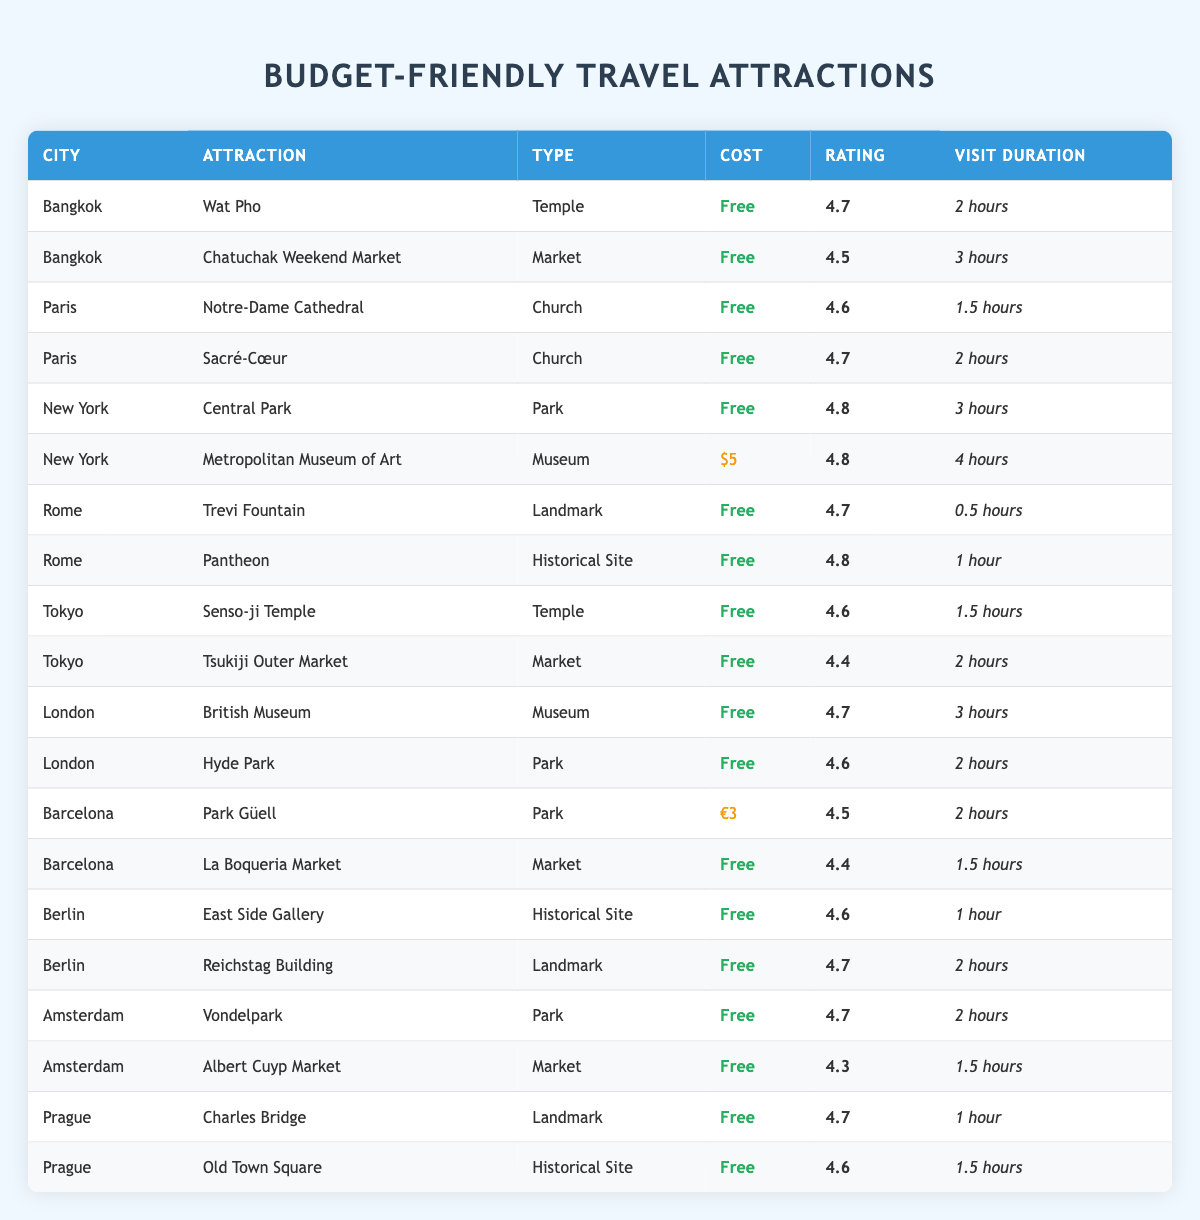What are the free attractions in Paris? In the table, the attractions in Paris that are marked as free are Notre-Dame Cathedral and Sacré-Cœur. I can identify these by checking the Cost column for a value of 0 associated with Paris.
Answer: Notre-Dame Cathedral, Sacré-Cœur Which city features the highest-rated free park? Central Park in New York has a rating of 4.8, the highest for a park in the table. While there are other free parks, such as Hyde Park and Vondelpark, their ratings are 4.6 and 4.7, respectively.
Answer: New York How many hours can you spend visiting the free attractions in Bangkok? The visit durations for free attractions in Bangkok are Wat Pho (2 hours) and Chatuchak Weekend Market (3 hours). Summing those gives: 2 + 3 = 5 hours total.
Answer: 5 hours Is the Metropolitan Museum of Art considered a free attraction? The cost listed for the Metropolitan Museum of Art in New York is 5 dollars; therefore, it is not a free attraction. The answer to whether it's free is no.
Answer: No What is the average rating of free attractions in Rome? The free attractions in Rome are Trevi Fountain (4.7) and Pantheon (4.8). To find the average, I sum the ratings (4.7 + 4.8 = 9.5) and divide by the number of attractions (2), which gives us 9.5 / 2 = 4.75.
Answer: 4.75 Which city has more than one free attraction listed, and what are they? Looking at the table, both Bangkok and Paris have more than one free attraction. Bangkok has Wat Pho and Chatuchak Weekend Market, while Paris has Notre-Dame Cathedral and Sacré-Cœur.
Answer: Bangkok, Paris What is the total cost of entry for all the attractions listed in the table? In the Cost column, count the number of attractions that are free (0) and add the paid ones. The only paid attraction is the Metropolitan Museum of Art at $5 and Park Güell at €3, which is equivalent to $3. So 5 + 3 = 8 dollars total as the cost.
Answer: 8 dollars Which attraction in London takes the longest to visit? The attractions in London are the British Museum (3 hours) and Hyde Park (2 hours). Comparing these, the British Museum has the longer visit duration of 3 hours.
Answer: British Museum What free attraction in Berlin has a rating lower than 4.6? In Berlin, all attractions listed as free—East Side Gallery (4.6) and Reichstag Building (4.7)—have ratings of 4.6 or above. Thus, there is no free attraction that fits the criteria of a rating lower than 4.6.
Answer: No 